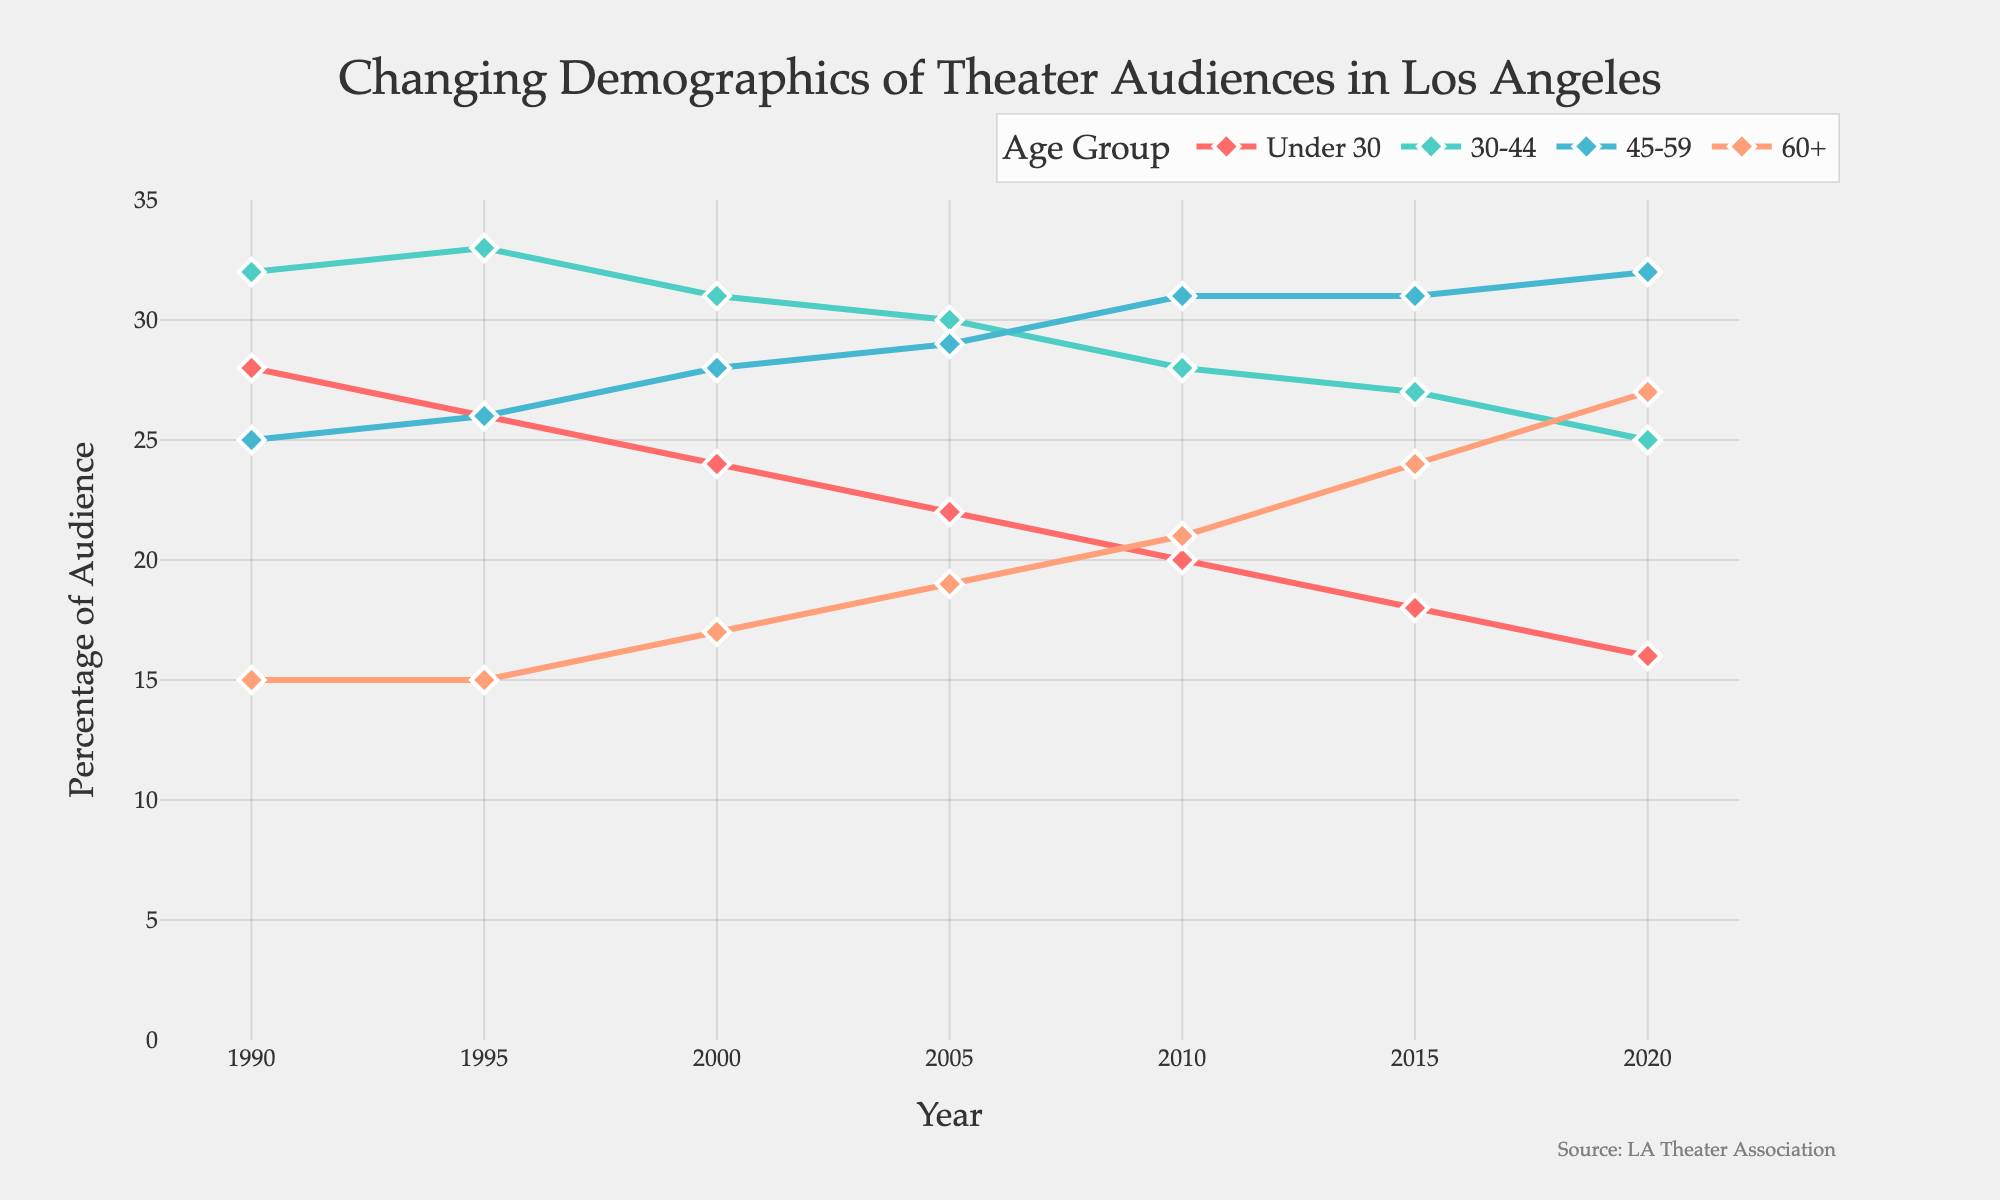How has the percentage of the audience under 30 changed from 1990 to 2020? Compare the values for the "Under 30" age group in the years 1990 and 2020. In 1990, the percentage was 28%, and in 2020, it was 16%. The change is 28% - 16% = 12%.
Answer: 12% Which age group showed the most significant increase in their percentage share from 1990 to 2020? Compare the changes from 1990 to 2020 for each age group. For "Under 30," it's a decrease of 12%; for "30-44," it's a decrease of 7%; for "45-59," it's an increase of 7%; for "60+," it's an increase of 12%. "60+" showed the largest increase.
Answer: 60+ Between which two consecutive years did the "45-59" age group see the largest increase in their percentage share? Look at the increments from one year to the next for the "45-59" age group. The changes are: 1990-1995: 1%, 1995-2000: 2%, 2000-2005: 1%, 2005-2010: 2%, 2010-2015: 0%, 2015-2020: 1%. The largest increase occurs between 1995 and 2000.
Answer: 1995 and 2000 Which age group had the highest percentage of the audience in 2010? Compare the percentages of all age groups in 2010. The "60+" group had 21%, "45-59" had 31%, "30-44" had 28%, and "Under 30" had 20%. The "45-59" group had the highest percentage.
Answer: 45-59 What was the average percentage share of the "30-44" age group over the three decades? Sum the values for "30-44" from 1990 to 2020 and divide by the number of data points: (32 + 33 + 31 + 30 + 28 + 27 + 25) / 7 = 206 / 7 ≈ 29.43%.
Answer: 29.43% By how much did the percentage of the "60+" age group change from 2000 to 2010? Subtract the "60+" percentage in 2000 from the percentage in 2010. It was 17% in 2000 and 21% in 2010. So, 21% - 17% = 4%.
Answer: 4% In which year did the "Under 30" age group witness a significant drop relative to the previous interval? Examine the changes year by year for the "Under 30" group. The drops are: 1990-1995: 2%, 1995-2000: 2%, 2000-2005: 2%, 2005-2010: 2%, 2010-2015: 2%, 2015-2020: 2%. All intervals are equal, indicating a consistent drop.
Answer: Consistent drop across intervals 